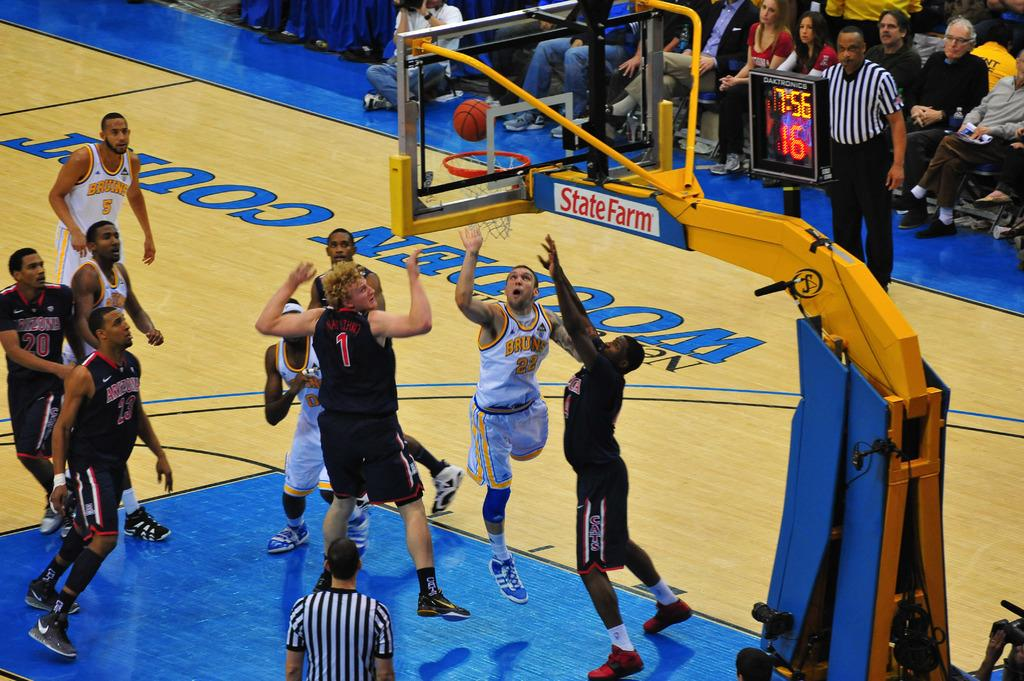<image>
Render a clear and concise summary of the photo. A Bruins basketball player shoots the ball towards a state farm net. 